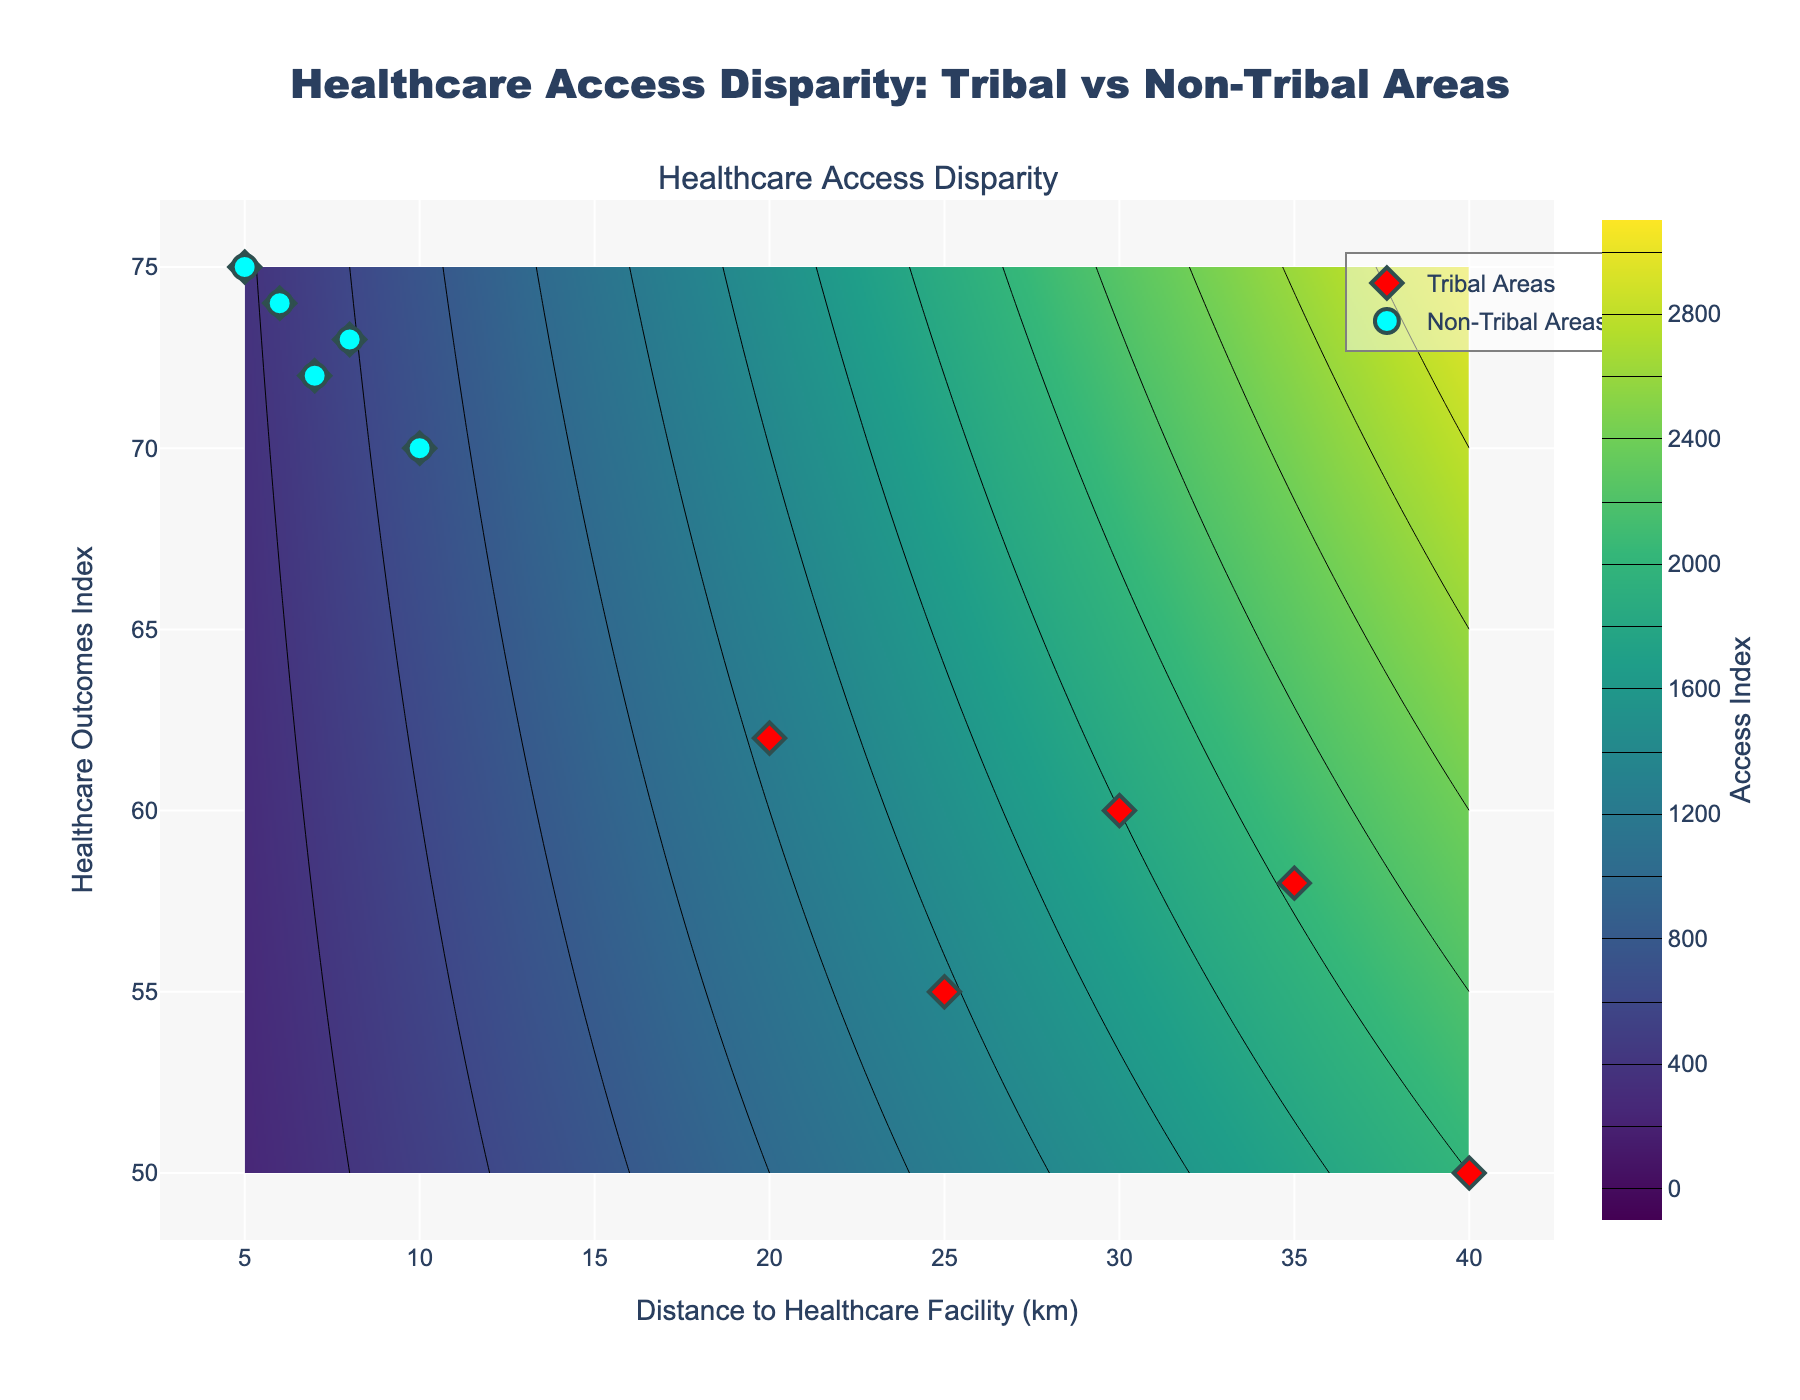what is the main title of the figure? The main title is written at the top of the figure and indicates the central topic.
Answer: Healthcare Access Disparity: Tribal vs Non-Tribal Areas How many data points represent tribal areas in this plot? The red markers signify tribal areas in the scatter plot. Counting them, there are 5 red markers.
Answer: 5 What is the range of distances to healthcare facilities in tribal areas? Locate the tribal area markers on the x-axis, which denotes distances to healthcare facilities. The minimum is 20 km, and the maximum is 40 km.
Answer: 20 km to 40 km What's the difference between the highest healthcare outcomes index in non-tribal areas and the highest in tribal areas? The highest value in non-tribal areas (cyan markers) is 75, and in tribal areas (red markers), it is 62. The difference is 75 - 62 = 13.
Answer: 13 Which group generally has better healthcare outcomes, tribal or non-tribal areas? By comparing the vertical positions of the red and cyan markers (representing healthcare outcomes), the non-tribal areas generally have higher healthcare outcomes indices.
Answer: Non-Tribal Areas Are there any non-tribal areas closer to healthcare facilities than the closest tribal area? The minimum distance for non-tribal areas is 5 km, while the closest tribal area is 20 km away. Thus, non-tribal areas have closer access points.
Answer: Yes How many contours are present in the heatmap, excluding the starting point? There are contours starting from 0 and incrementing by 200 up to a maximum of 3000. Count the intervals: (3000 - 0) / 200 = 15.
Answer: 15 What is the color of the heatmap for areas with the highest access index values? The colorscale "Viridis" transitions from dark blue to yellow-green; the highest values are in yellow-greenish colors.
Answer: Yellow-green If the distance to a healthcare facility increases, how does the healthcare outcome index generally trend for tribal areas? For tribal areas (red markers), as the distance increases from 20 to 40 km, the healthcare outcomes index tends to decrease (62 to 50).
Answer: Decreases 